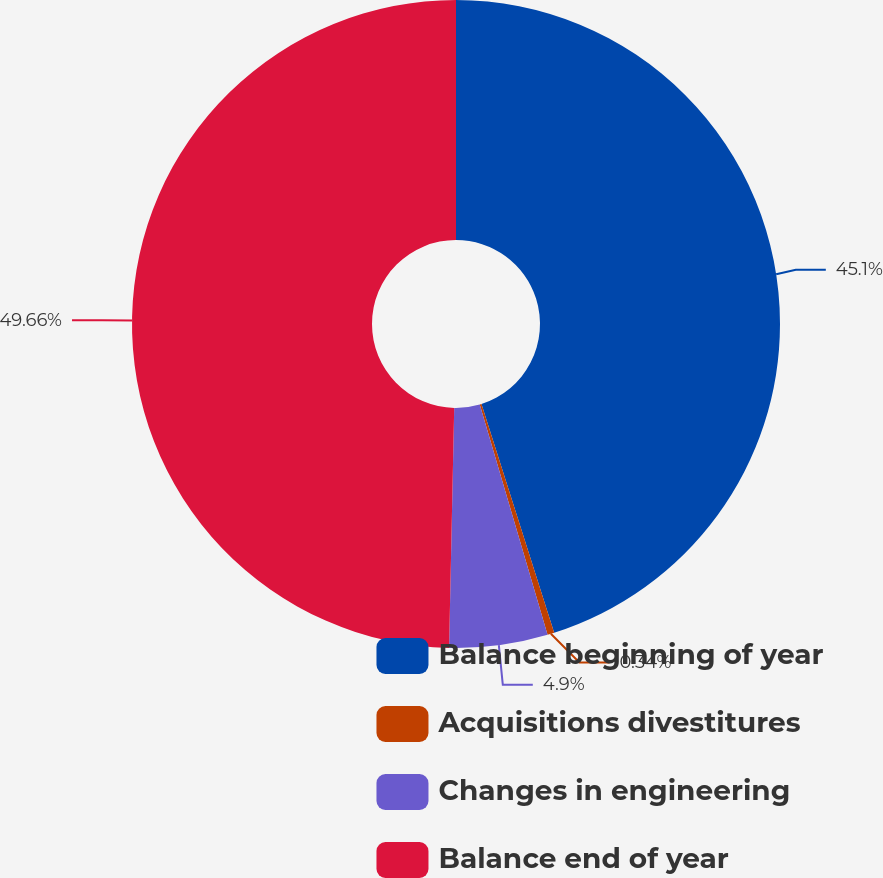Convert chart. <chart><loc_0><loc_0><loc_500><loc_500><pie_chart><fcel>Balance beginning of year<fcel>Acquisitions divestitures<fcel>Changes in engineering<fcel>Balance end of year<nl><fcel>45.1%<fcel>0.34%<fcel>4.9%<fcel>49.66%<nl></chart> 